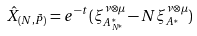Convert formula to latex. <formula><loc_0><loc_0><loc_500><loc_500>\hat { X } _ { ( N , \tilde { P } ) } & = e ^ { - t } ( \xi _ { A ^ { \ast } _ { N ^ { \ast } } } ^ { \nu \otimes \mu } - N \xi _ { A ^ { \ast } } ^ { \nu \otimes \mu } )</formula> 